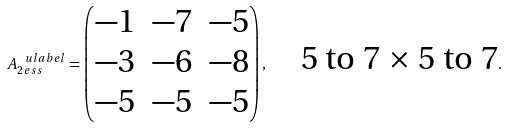<formula> <loc_0><loc_0><loc_500><loc_500>A _ { 2 \, e s s } ^ { \ u l a b e l } = \begin{pmatrix} - 1 & - 7 & - 5 \\ - 3 & - 6 & - 8 \\ - 5 & - 5 & - 5 \end{pmatrix} , \quad \text {5 to 7 $\times$ 5 to 7} .</formula> 